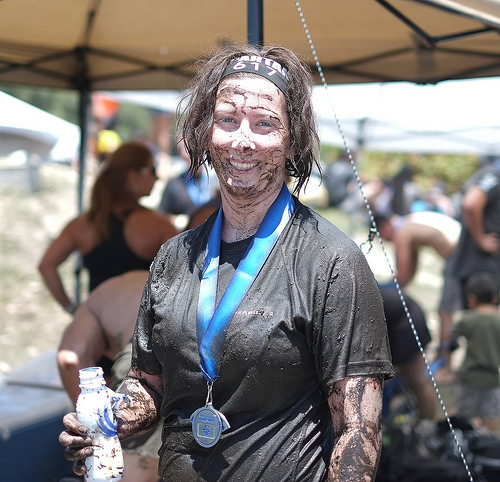<image>
Is there a boy behind the woman? Yes. From this viewpoint, the boy is positioned behind the woman, with the woman partially or fully occluding the boy. 